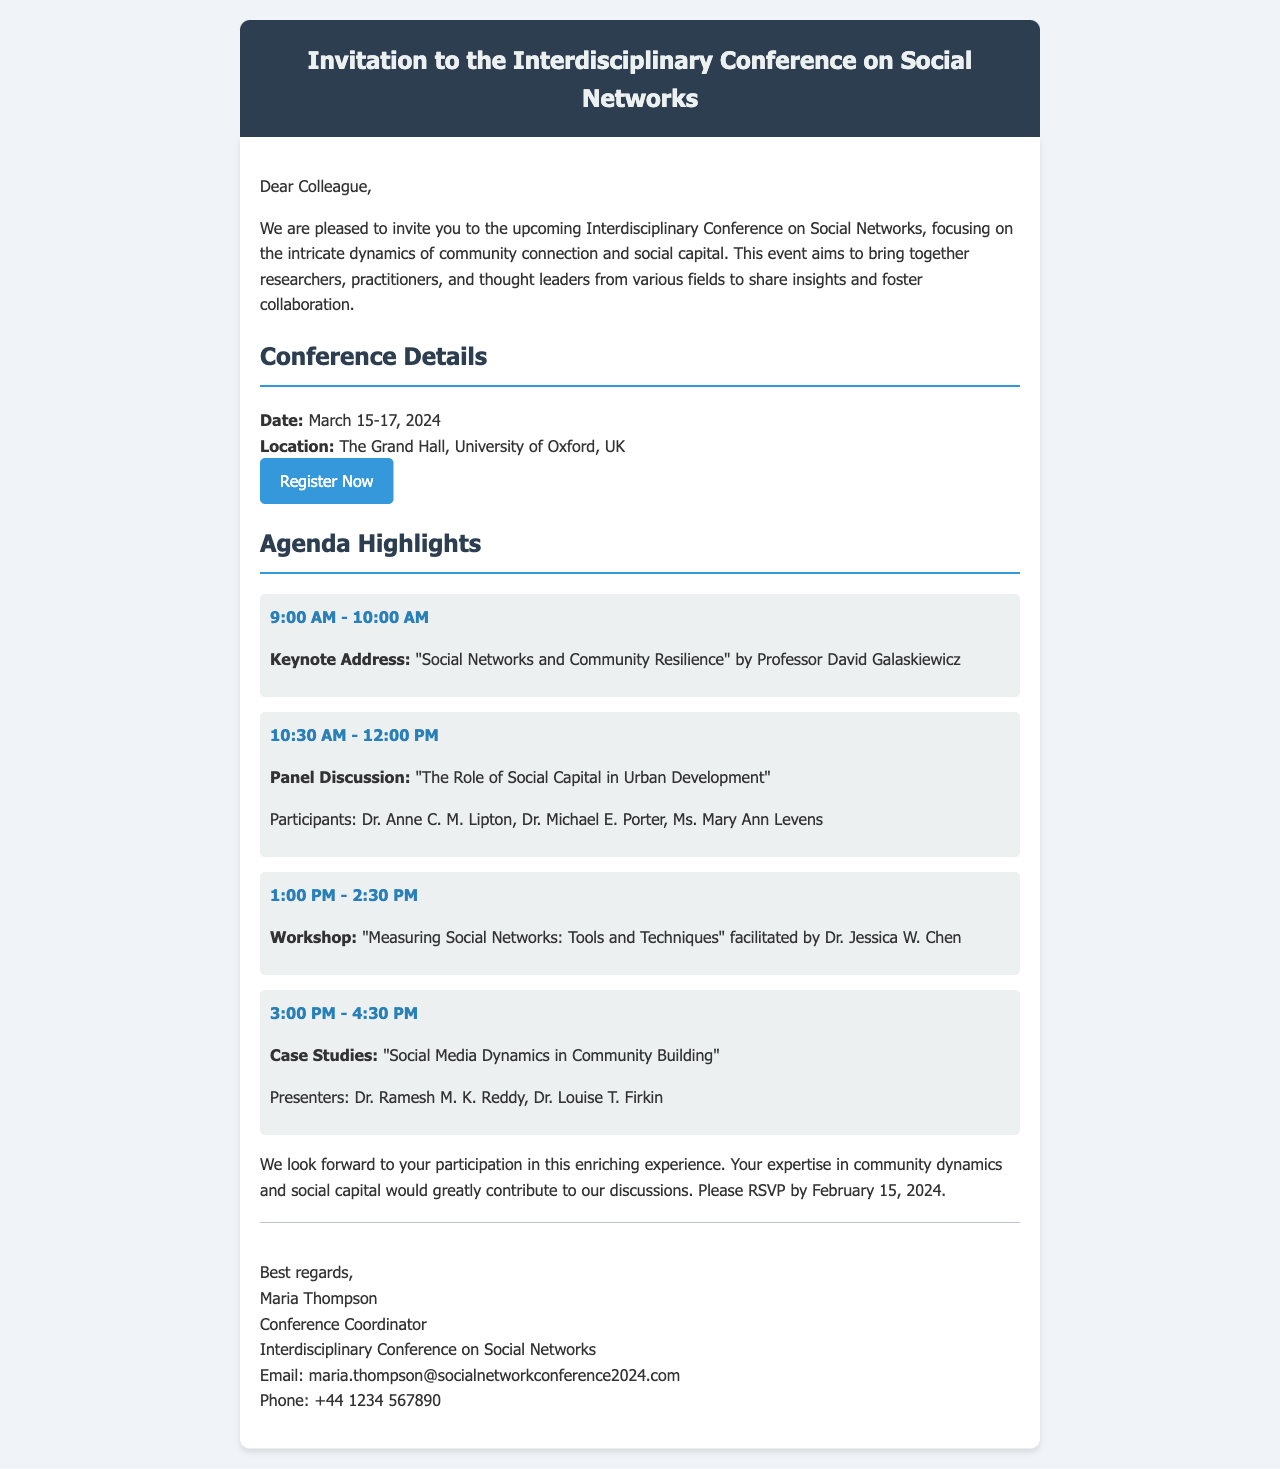What are the conference dates? The conference dates are specified in the document.
Answer: March 15-17, 2024 Where is the conference located? The location of the conference is mentioned in the details section.
Answer: The Grand Hall, University of Oxford, UK Who is giving the keynote address? The name of the speaker for the keynote address is provided in the agenda highlights.
Answer: Professor David Galaskiewicz What time does the panel discussion start? The start time for the panel discussion is included in the agenda section.
Answer: 10:30 AM What is the topic of the workshop? The workshop topic is listed in the agenda highlights.
Answer: Measuring Social Networks: Tools and Techniques What is the RSVP deadline? The RSVP deadline is stated clearly at the end of the document.
Answer: February 15, 2024 How many keynote speakers are mentioned? The total number of keynote speakers can be counted from the agenda.
Answer: One Which session discusses social media dynamics? The session that discusses social media dynamics is indicated in the agenda items.
Answer: Case Studies: "Social Media Dynamics in Community Building" What is the email address of the conference coordinator? The email address of the conference coordinator is provided in the signature section.
Answer: maria.thompson@socialnetworkconference2024.com 